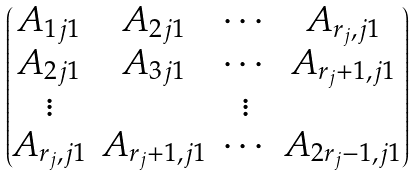<formula> <loc_0><loc_0><loc_500><loc_500>\begin{pmatrix} A _ { 1 j 1 } & A _ { 2 j 1 } & \cdots & A _ { r _ { j } , j 1 } \\ A _ { 2 j 1 } & A _ { 3 j 1 } & \cdots & A _ { r _ { j } + 1 , j 1 } \\ \vdots & & \vdots \\ A _ { r _ { j } , j 1 } & A _ { r _ { j } + 1 , j 1 } & \cdots & A _ { 2 r _ { j } - 1 , j 1 } \\ \end{pmatrix}</formula> 